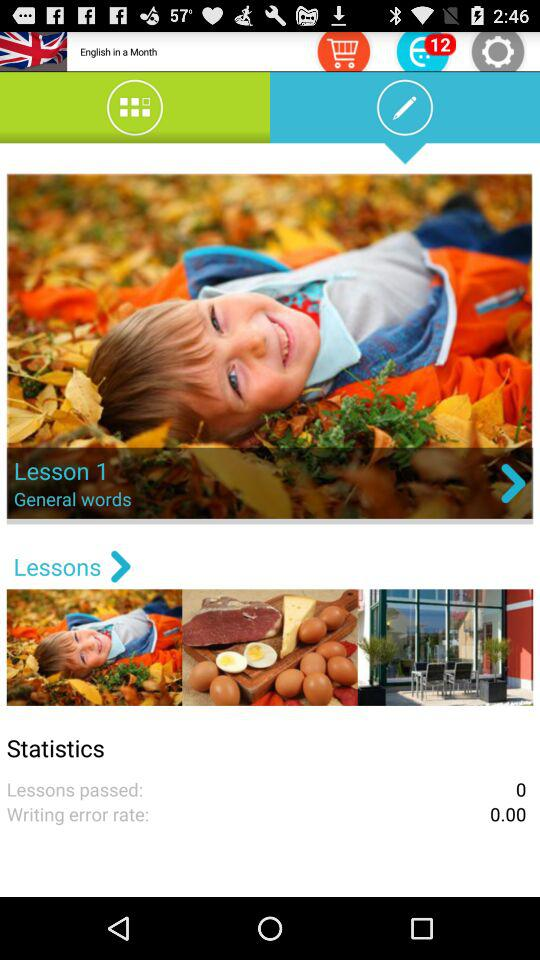What is the number of notifications? The number of notifications is 12. 